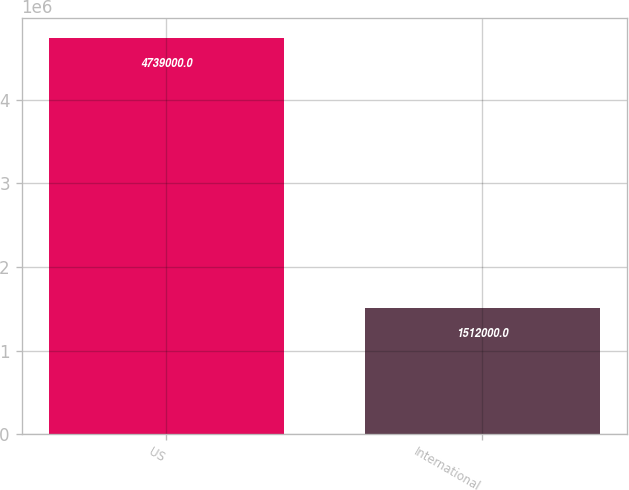Convert chart. <chart><loc_0><loc_0><loc_500><loc_500><bar_chart><fcel>US<fcel>International<nl><fcel>4.739e+06<fcel>1.512e+06<nl></chart> 